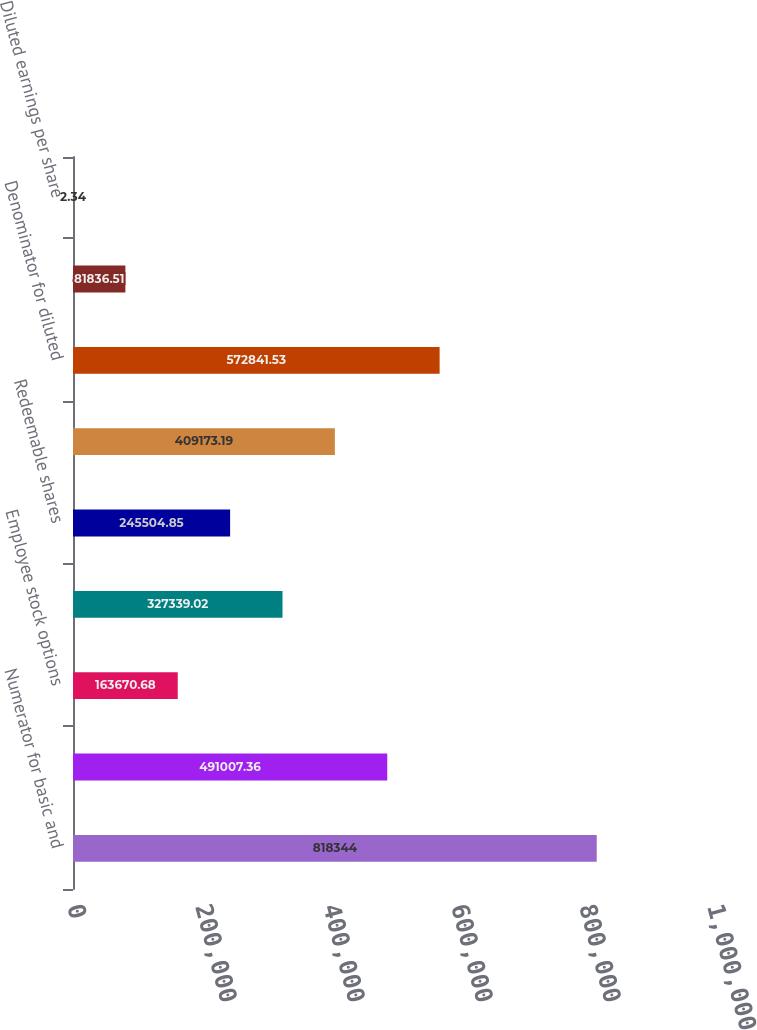Convert chart to OTSL. <chart><loc_0><loc_0><loc_500><loc_500><bar_chart><fcel>Numerator for basic and<fcel>Denominator for basic earnings<fcel>Employee stock options<fcel>Non-vested restricted shares<fcel>Redeemable shares<fcel>Dilutive potential common<fcel>Denominator for diluted<fcel>Basic earnings per share<fcel>Diluted earnings per share<nl><fcel>818344<fcel>491007<fcel>163671<fcel>327339<fcel>245505<fcel>409173<fcel>572842<fcel>81836.5<fcel>2.34<nl></chart> 